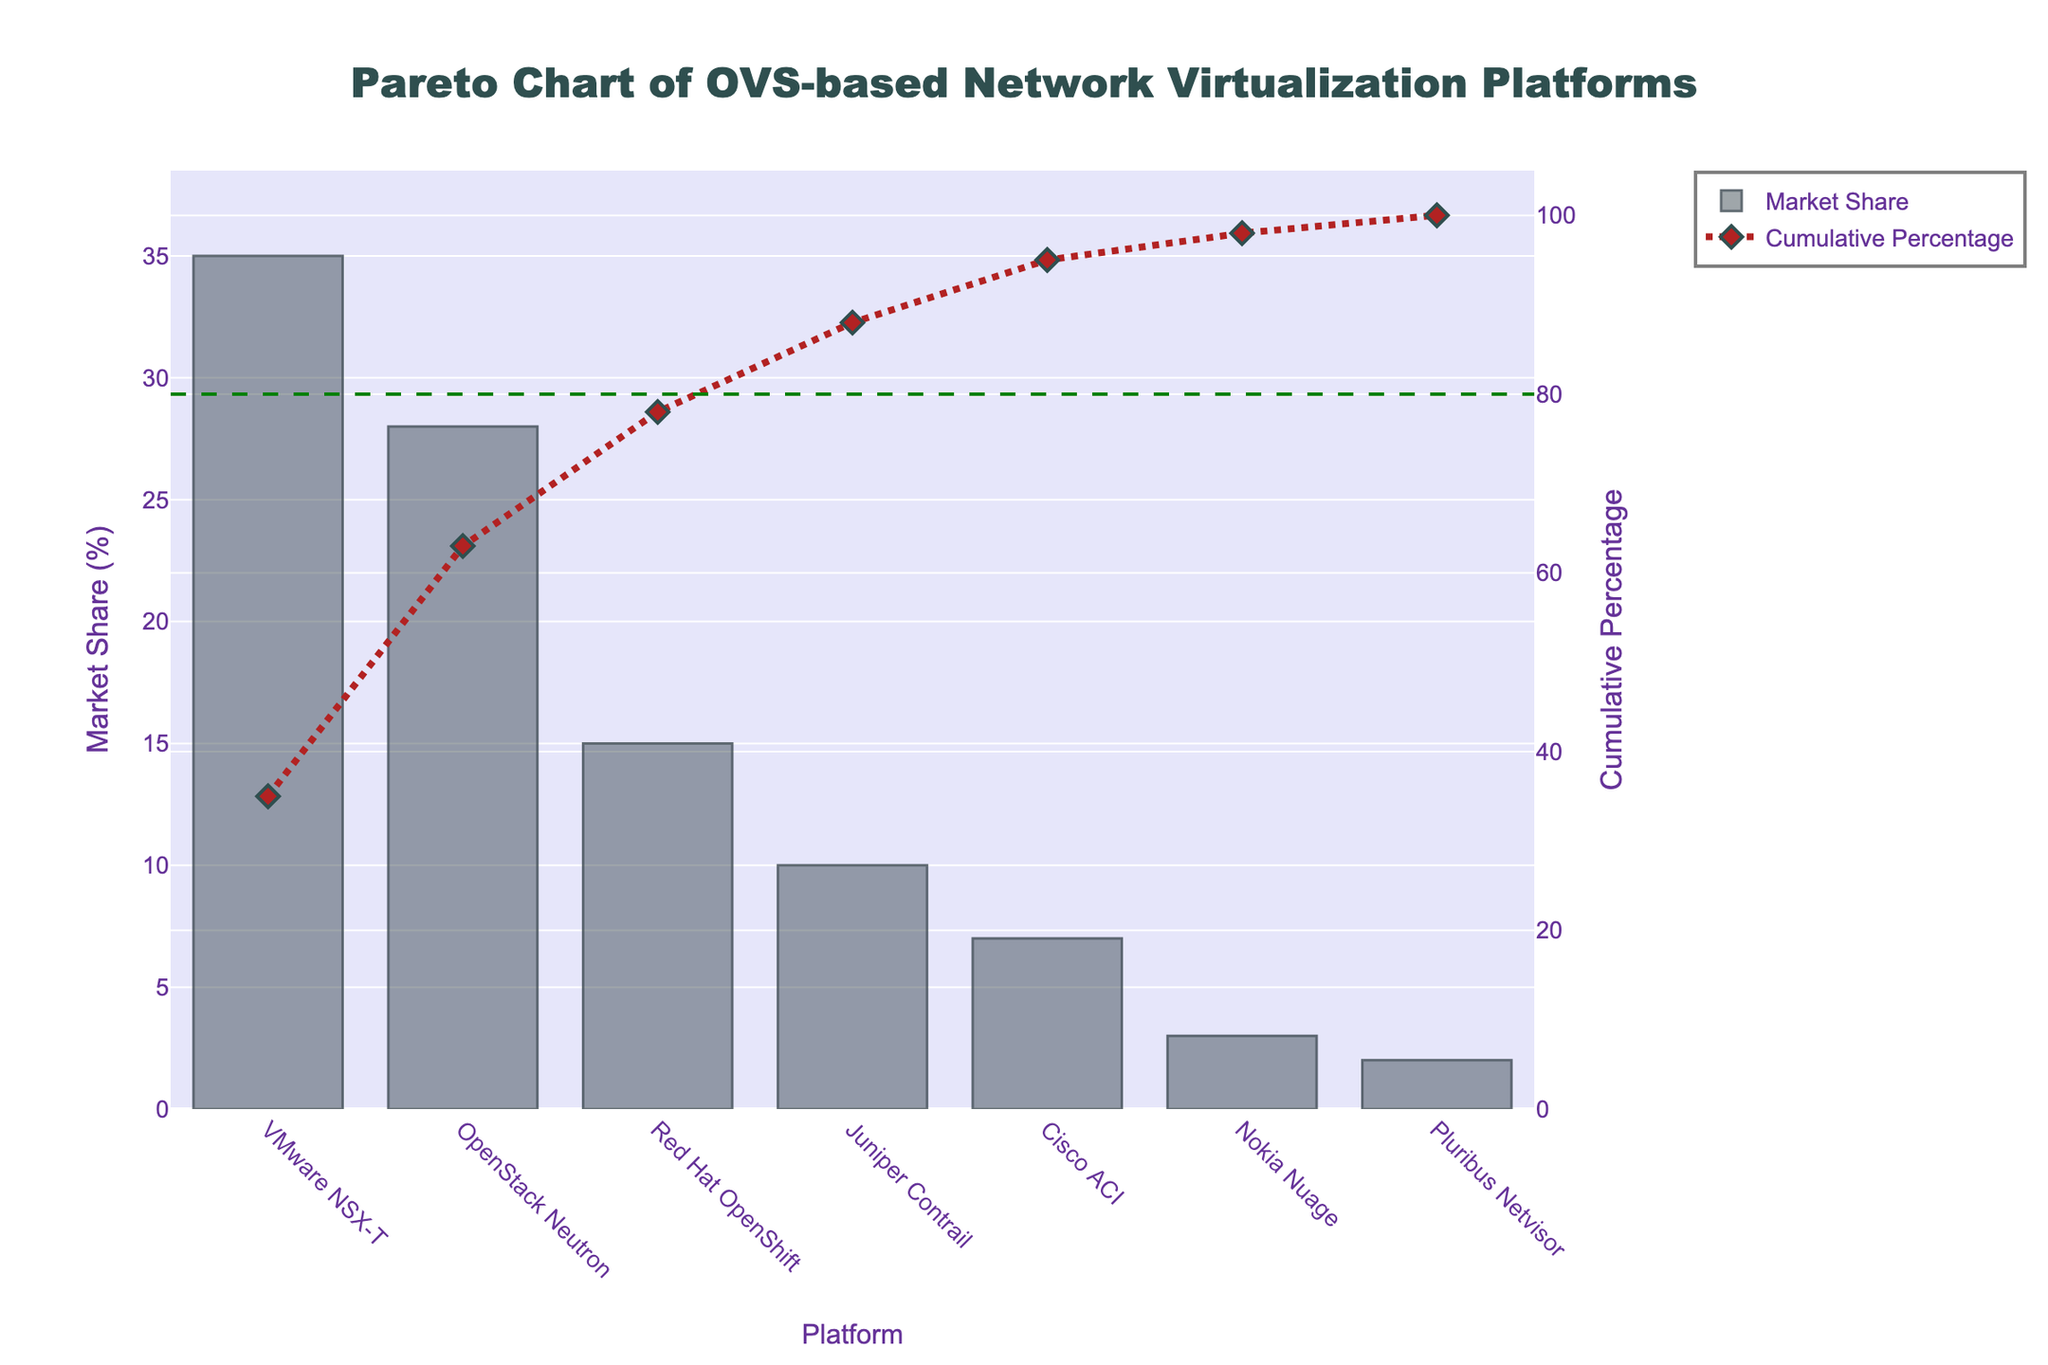What is the title of the figure? The title is typically found at the top of the figure and describes its main subject. Here, we observe its position and the text used.
Answer: Pareto Chart of OVS-based Network Virtualization Platforms What color is used for the Market Share bars? The colors of the elements in the plot can be determined by visually inspecting the bars. In this case, we are looking for the color of the bars representing Market Share.
Answer: Gray Which platform has the highest market share? By examining the height of the bars, we can identify which platform has the largest value in terms of Market Share (%). The x-axis labels will help determine the platform name.
Answer: VMware NSX-T What is the cumulative percentage for Red Hat OpenShift? Find the Red Hat OpenShift label along the x-axis and then trace its corresponding point on the Cumulative Percentage line. Read the value on the secondary y-axis.
Answer: 78% Which platforms together contribute to approximately 80% of the cumulative market share? Identify the platforms by following the Cumulative Percentage line to see which platforms contribute to a cumulative percentage close to 80%. Stop when reaching or exceeding 80%.
Answer: VMware NSX-T, OpenStack Neutron, Red Hat OpenShift How does the cumulative percentage change between Juniper Contrail and Red Hat OpenShift? Locate Juniper Contrail and Red Hat OpenShift on the x-axis, then compare their respective points on the Cumulative Percentage line by reading the percentages from the secondary y-axis. Subtract the smaller percentage from the larger one.
Answer: It increases by 15% (78% - 63%) Which platform has the smallest market share? By checking the shortest bar along the y-axis, determine the platform name from the x-axis label beneath it.
Answer: Pluribus Netvisor What is the market share difference between Cisco ACI and Nokia Nuage? Locate Cisco ACI and Nokia Nuage along the x-axis, then subtract the smaller Market Share percentage from the larger one by using the Main y-axis.
Answer: 4% (7% - 3%) How many platforms together achieve the 80% reference line for cumulative percentage? Trace the Cumulative Percentage line to identify the point where it crosses or meets the 80% reference line and count the platforms included up to this point.
Answer: 3 What distinguishes the Cumulative Percentage line visually? Describe the visual characteristics, such as color, shape, and style, of the Cumulative Percentage line by examining the figure.
Answer: It's a firebrick color, dashed line with diamond markers 